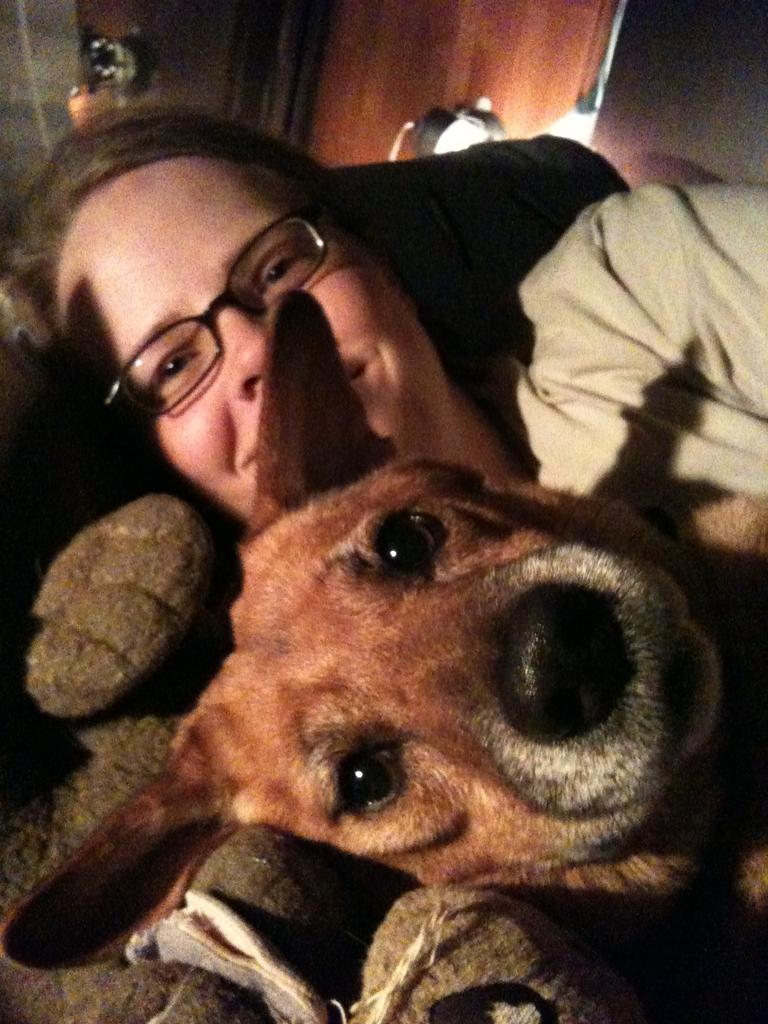Who is present in the image? There is a woman in the image. What is the woman wearing? The woman is wearing spectacles. What other living creature is in the image? There is a dog in the image. What can be seen in the background of the image? There appears to be a door in the background of the image. What are the woman's hobbies, and how do they relate to her income in the image? There is no information about the woman's hobbies or income in the image. 